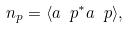<formula> <loc_0><loc_0><loc_500><loc_500>n _ { p } = \langle a _ { \ } p ^ { * } a _ { \ } p \rangle ,</formula> 